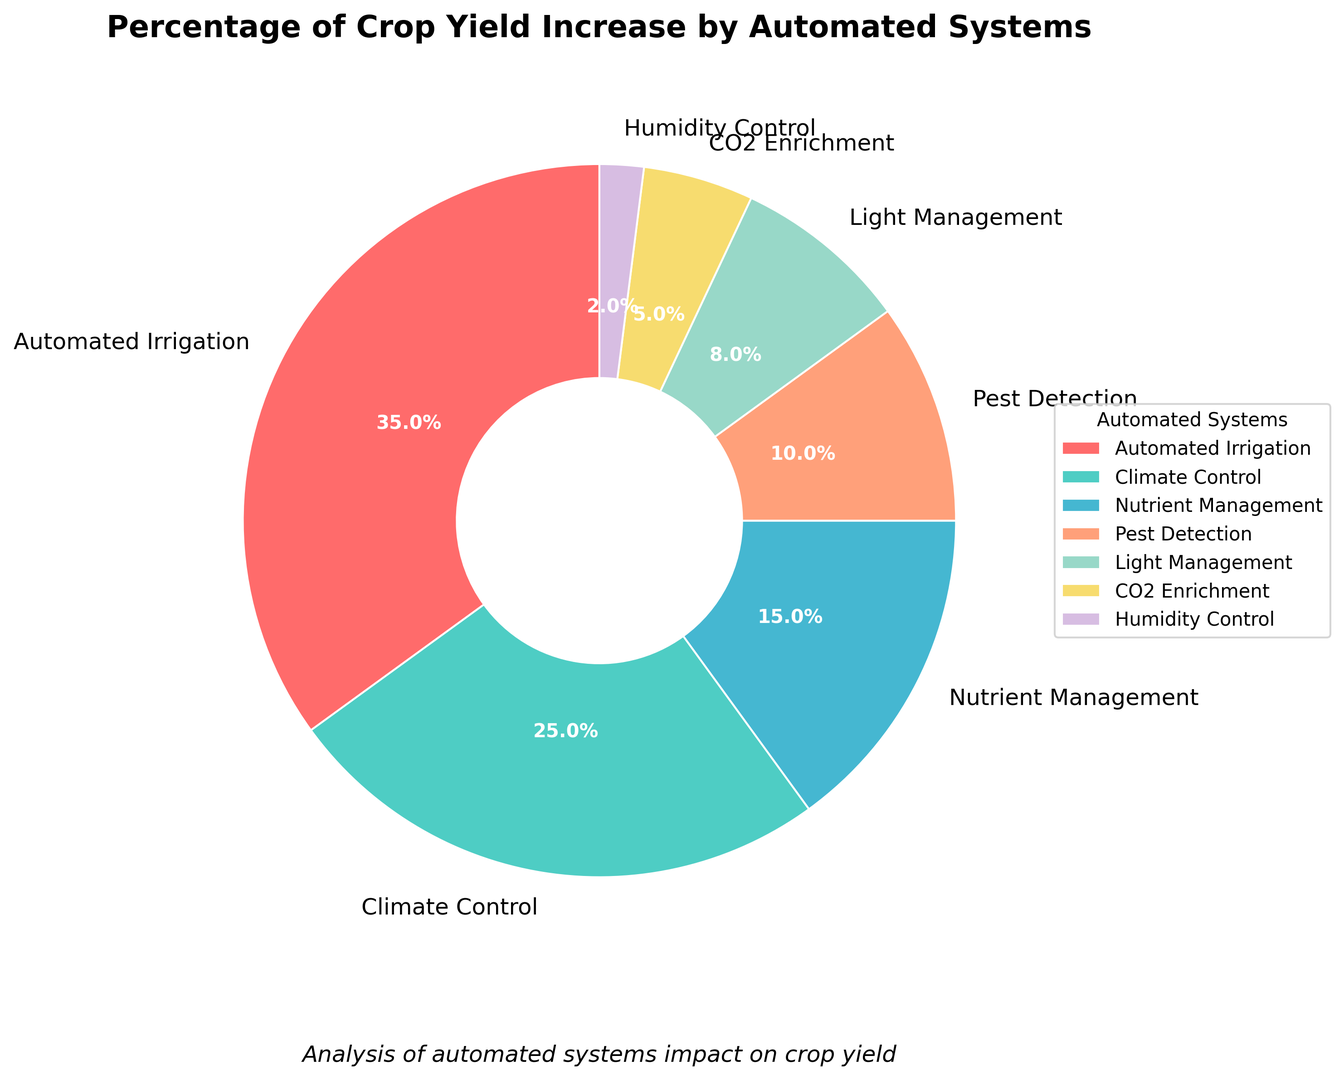Which automated system contributes the most to crop yield increase? The system with the largest percentage slice in the pie chart is Automated Irrigation, with a contribution of 35%.
Answer: Automated Irrigation Which automated system contributes the least to crop yield increase? The system with the smallest percentage slice in the pie chart is Humidity Control, with a contribution of 2%.
Answer: Humidity Control How much more does Climate Control contribute to crop yield increase compared to Nutrient Management? Climate Control contributes 25%, whereas Nutrient Management contributes 15%. The difference is 25% - 15% = 10%.
Answer: 10% What is the combined contribution of Light Management and CO2 Enrichment systems to crop yield increase? Light Management contributes 8%, and CO2 Enrichment contributes 5%. The combined contribution is 8% + 5% = 13%.
Answer: 13% Are there any systems with an equal or greater contribution than Climate Control? Climate Control contributes 25%. The only other system with an equal or greater contribution is Automated Irrigation, contributing 35%.
Answer: Yes What is the average contribution of Pest Detection, Light Management, and Humidity Control? Pest Detection contributes 10%, Light Management contributes 8%, and Humidity Control contributes 2%. The average is (10% + 8% + 2%) / 3 ≈ 6.67%.
Answer: 6.67% What percentage of crop yield increase is attributed to systems other than Climate Control and Automated Irrigation? The total contribution of Climate Control and Automated Irrigation is 25% + 35% = 60%. The remaining percentage is 100% - 60% = 40%.
Answer: 40% Compare the contributions of CO2 Enrichment and Humidity Control to crop yield increase. Which one is higher and by how much? CO2 Enrichment contributes 5%, while Humidity Control contributes 2%. The difference is 5% - 2% = 3%. CO2 Enrichment has a higher contribution by 3%.
Answer: CO2 Enrichment by 3% If you had to remove one system to decrease the complexity of your automation, which system's removal would minimize the impact on crop yield increase? The system with the smallest contribution to crop yield increase is Humidity Control at 2%, so removing it would have the least impact.
Answer: Humidity Control 